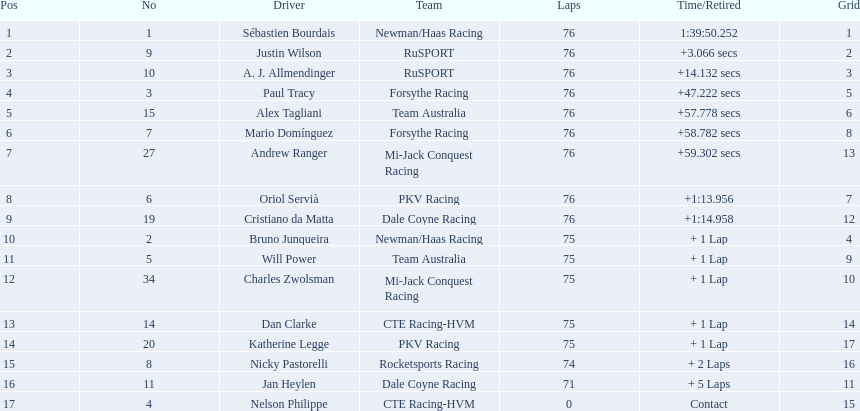What driver earned the most points? Sebastien Bourdais. Can you parse all the data within this table? {'header': ['Pos', 'No', 'Driver', 'Team', 'Laps', 'Time/Retired', 'Grid'], 'rows': [['1', '1', 'Sébastien Bourdais', 'Newman/Haas Racing', '76', '1:39:50.252', '1'], ['2', '9', 'Justin Wilson', 'RuSPORT', '76', '+3.066 secs', '2'], ['3', '10', 'A. J. Allmendinger', 'RuSPORT', '76', '+14.132 secs', '3'], ['4', '3', 'Paul Tracy', 'Forsythe Racing', '76', '+47.222 secs', '5'], ['5', '15', 'Alex Tagliani', 'Team Australia', '76', '+57.778 secs', '6'], ['6', '7', 'Mario Domínguez', 'Forsythe Racing', '76', '+58.782 secs', '8'], ['7', '27', 'Andrew Ranger', 'Mi-Jack Conquest Racing', '76', '+59.302 secs', '13'], ['8', '6', 'Oriol Servià', 'PKV Racing', '76', '+1:13.956', '7'], ['9', '19', 'Cristiano da Matta', 'Dale Coyne Racing', '76', '+1:14.958', '12'], ['10', '2', 'Bruno Junqueira', 'Newman/Haas Racing', '75', '+ 1 Lap', '4'], ['11', '5', 'Will Power', 'Team Australia', '75', '+ 1 Lap', '9'], ['12', '34', 'Charles Zwolsman', 'Mi-Jack Conquest Racing', '75', '+ 1 Lap', '10'], ['13', '14', 'Dan Clarke', 'CTE Racing-HVM', '75', '+ 1 Lap', '14'], ['14', '20', 'Katherine Legge', 'PKV Racing', '75', '+ 1 Lap', '17'], ['15', '8', 'Nicky Pastorelli', 'Rocketsports Racing', '74', '+ 2 Laps', '16'], ['16', '11', 'Jan Heylen', 'Dale Coyne Racing', '71', '+ 5 Laps', '11'], ['17', '4', 'Nelson Philippe', 'CTE Racing-HVM', '0', 'Contact', '15']]} 